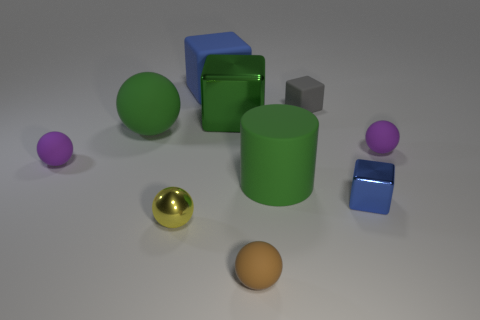Add 6 small gray matte cubes. How many small gray matte cubes are left? 7 Add 3 tiny matte spheres. How many tiny matte spheres exist? 6 Subtract all blue cubes. How many cubes are left? 2 Subtract all purple balls. How many balls are left? 3 Subtract 1 green spheres. How many objects are left? 9 Subtract all cylinders. How many objects are left? 9 Subtract 4 balls. How many balls are left? 1 Subtract all brown blocks. Subtract all purple spheres. How many blocks are left? 4 Subtract all red cylinders. How many green balls are left? 1 Subtract all brown rubber balls. Subtract all red matte things. How many objects are left? 9 